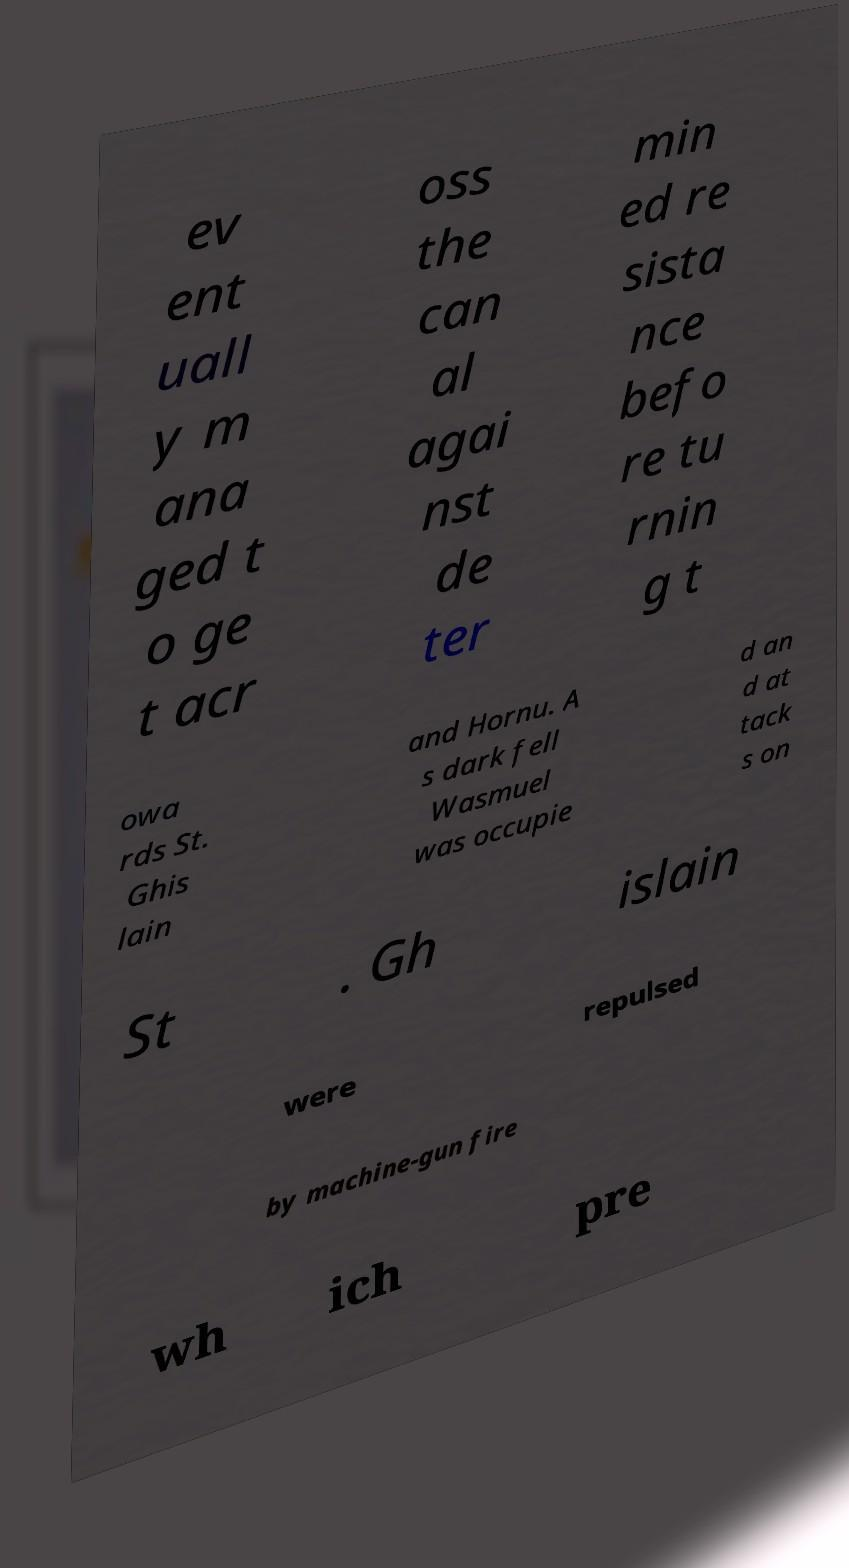Can you read and provide the text displayed in the image?This photo seems to have some interesting text. Can you extract and type it out for me? ev ent uall y m ana ged t o ge t acr oss the can al agai nst de ter min ed re sista nce befo re tu rnin g t owa rds St. Ghis lain and Hornu. A s dark fell Wasmuel was occupie d an d at tack s on St . Gh islain were repulsed by machine-gun fire wh ich pre 